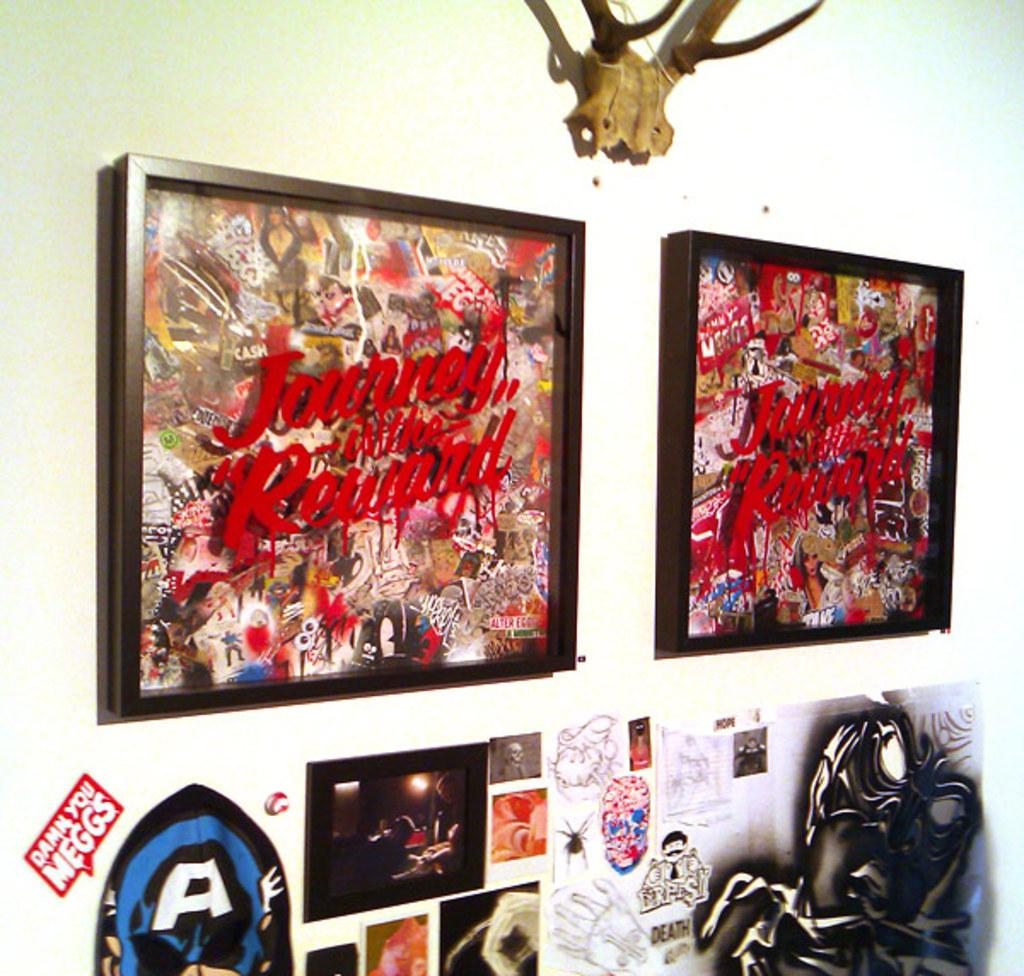<image>
Provide a brief description of the given image. A red and white sticker on the wall that states Damn, you Meggs. 